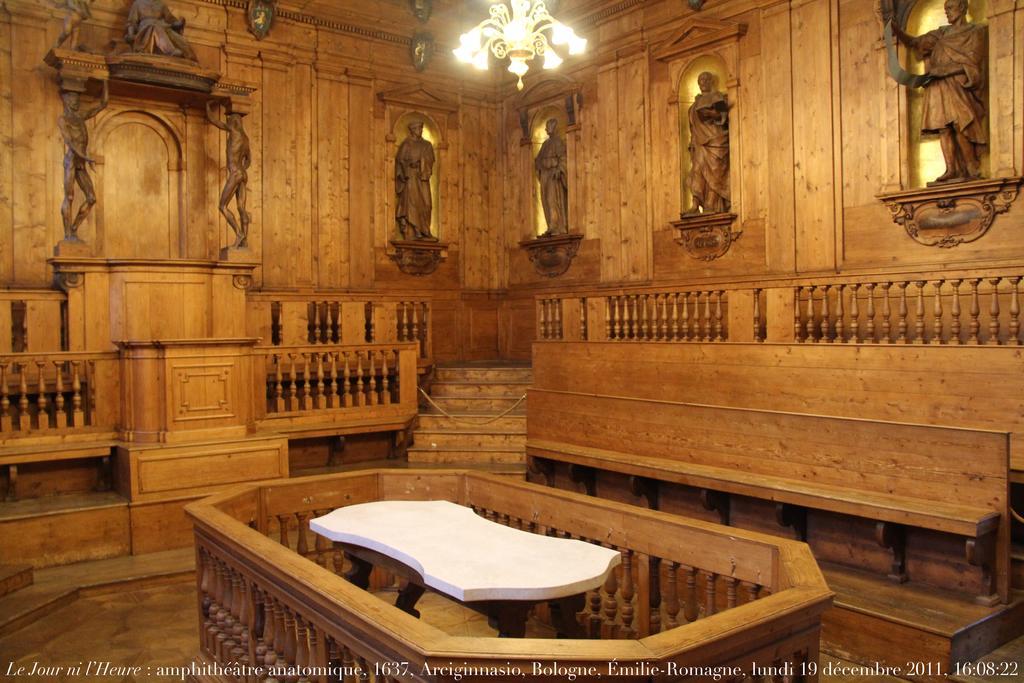Describe this image in one or two sentences. This is the inside picture of the building. In this image there are sculptures on the wall. In front of the sculptures there are stairs. In front of the image there is a table. Around the table there is a closed wooden fence. On top of the image there is a chandelier. There are is some text at the bottom of the image. 